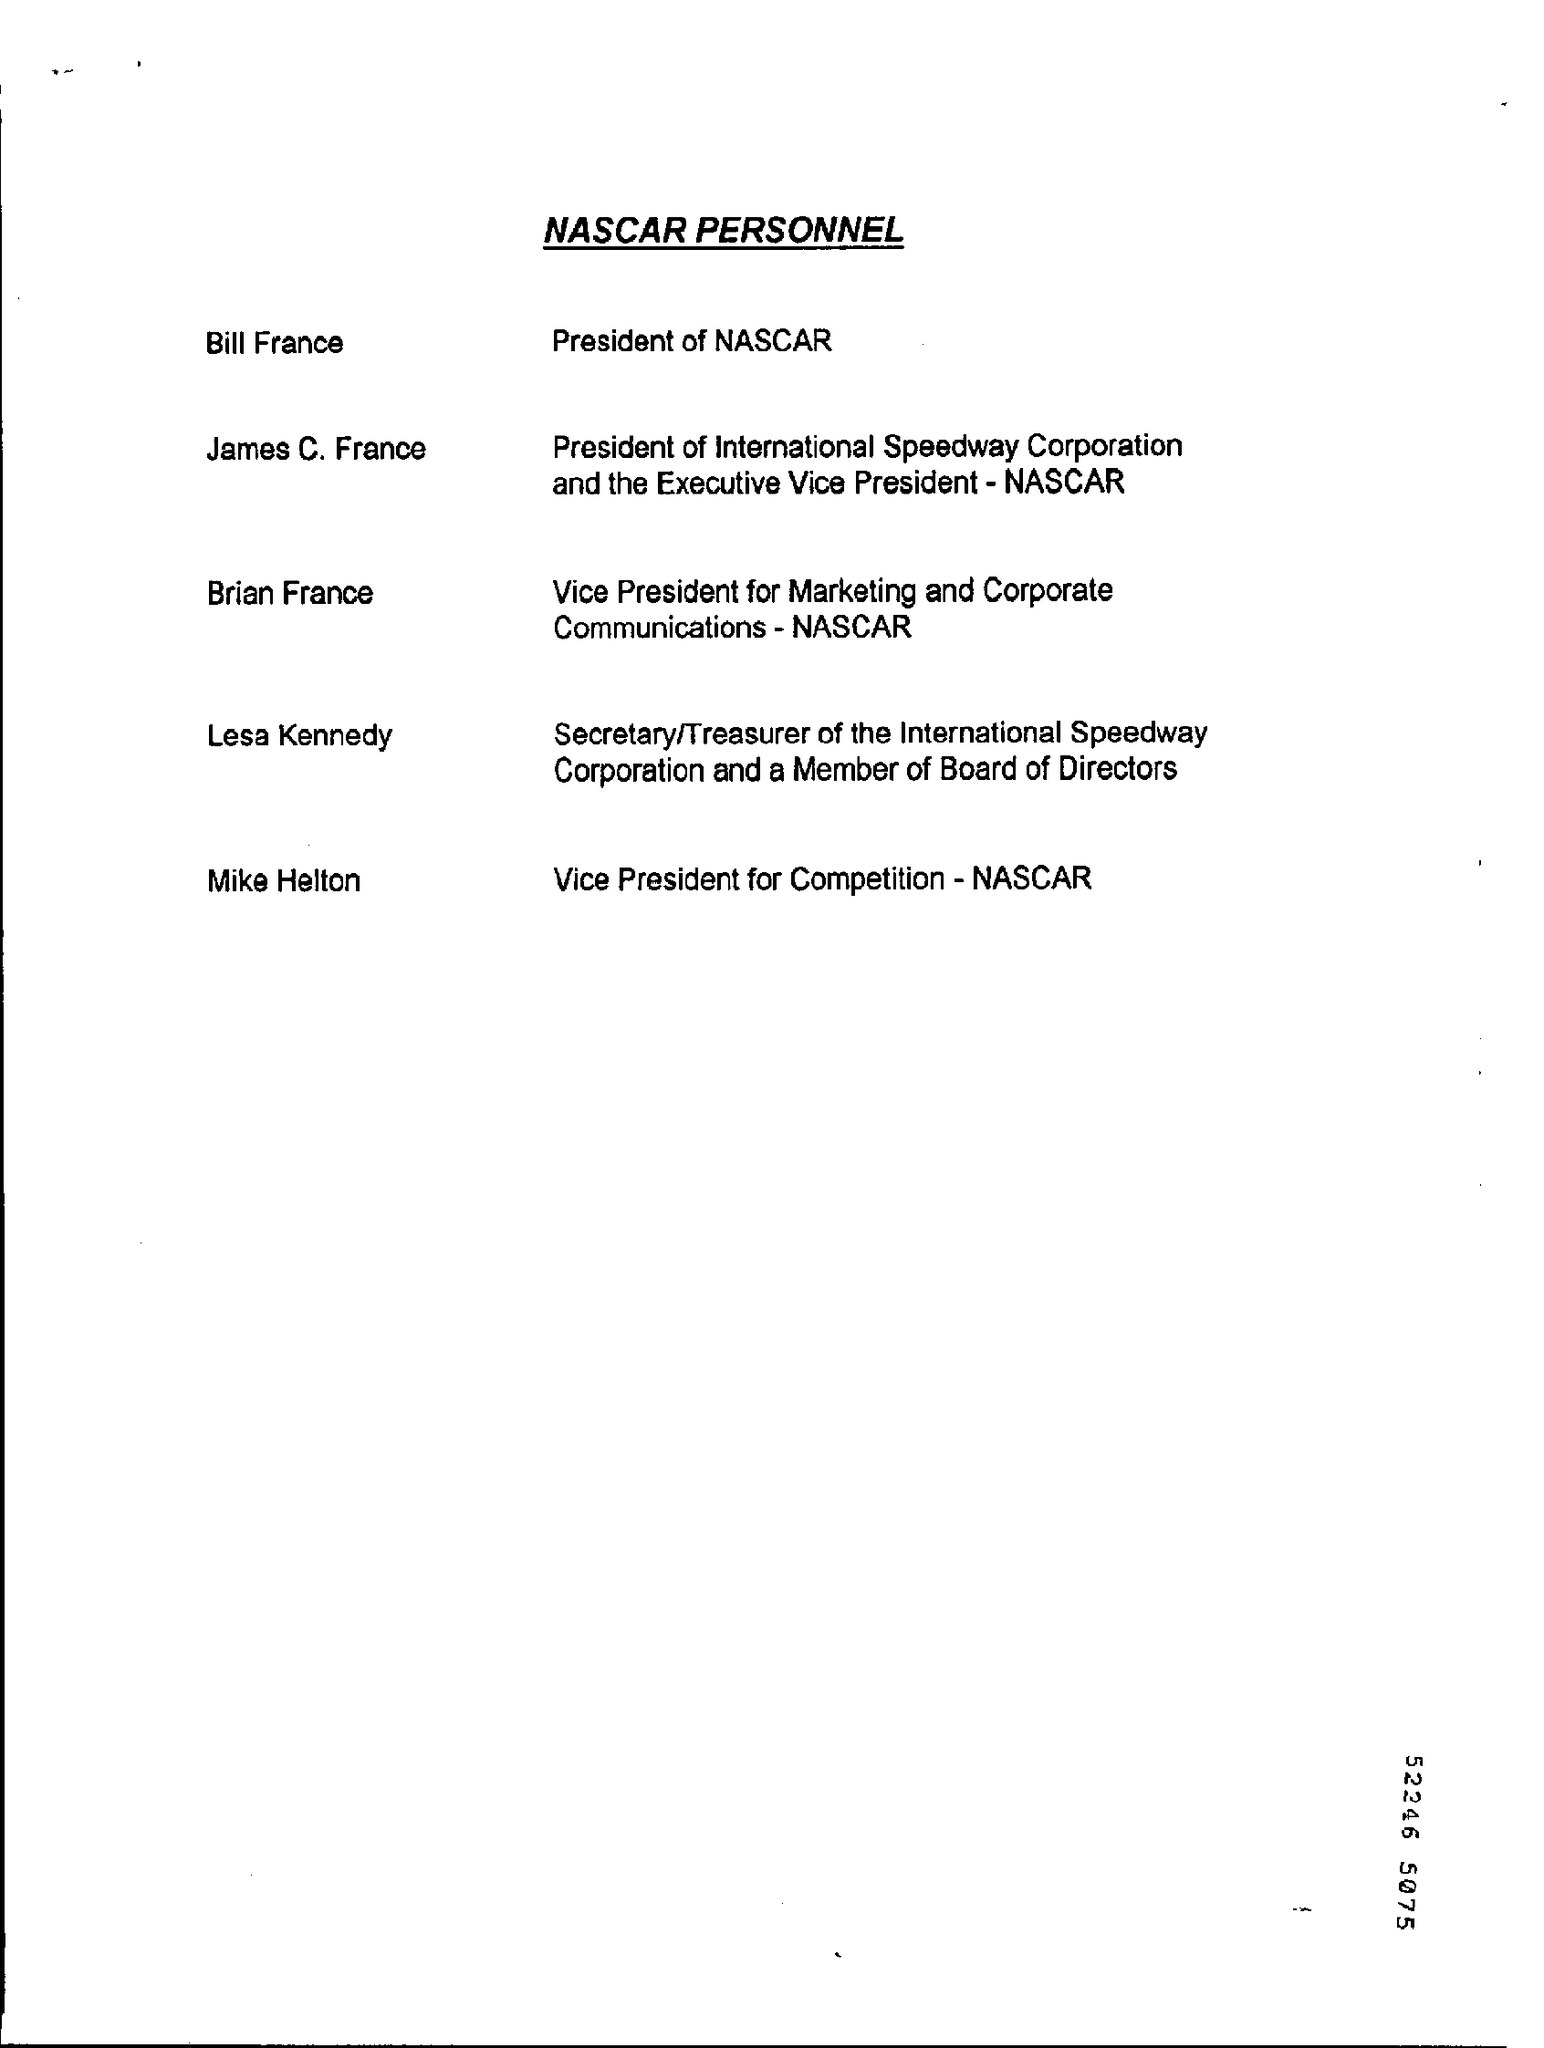Who is vice president of Competetion,
Provide a short and direct response. Mike Helton. 